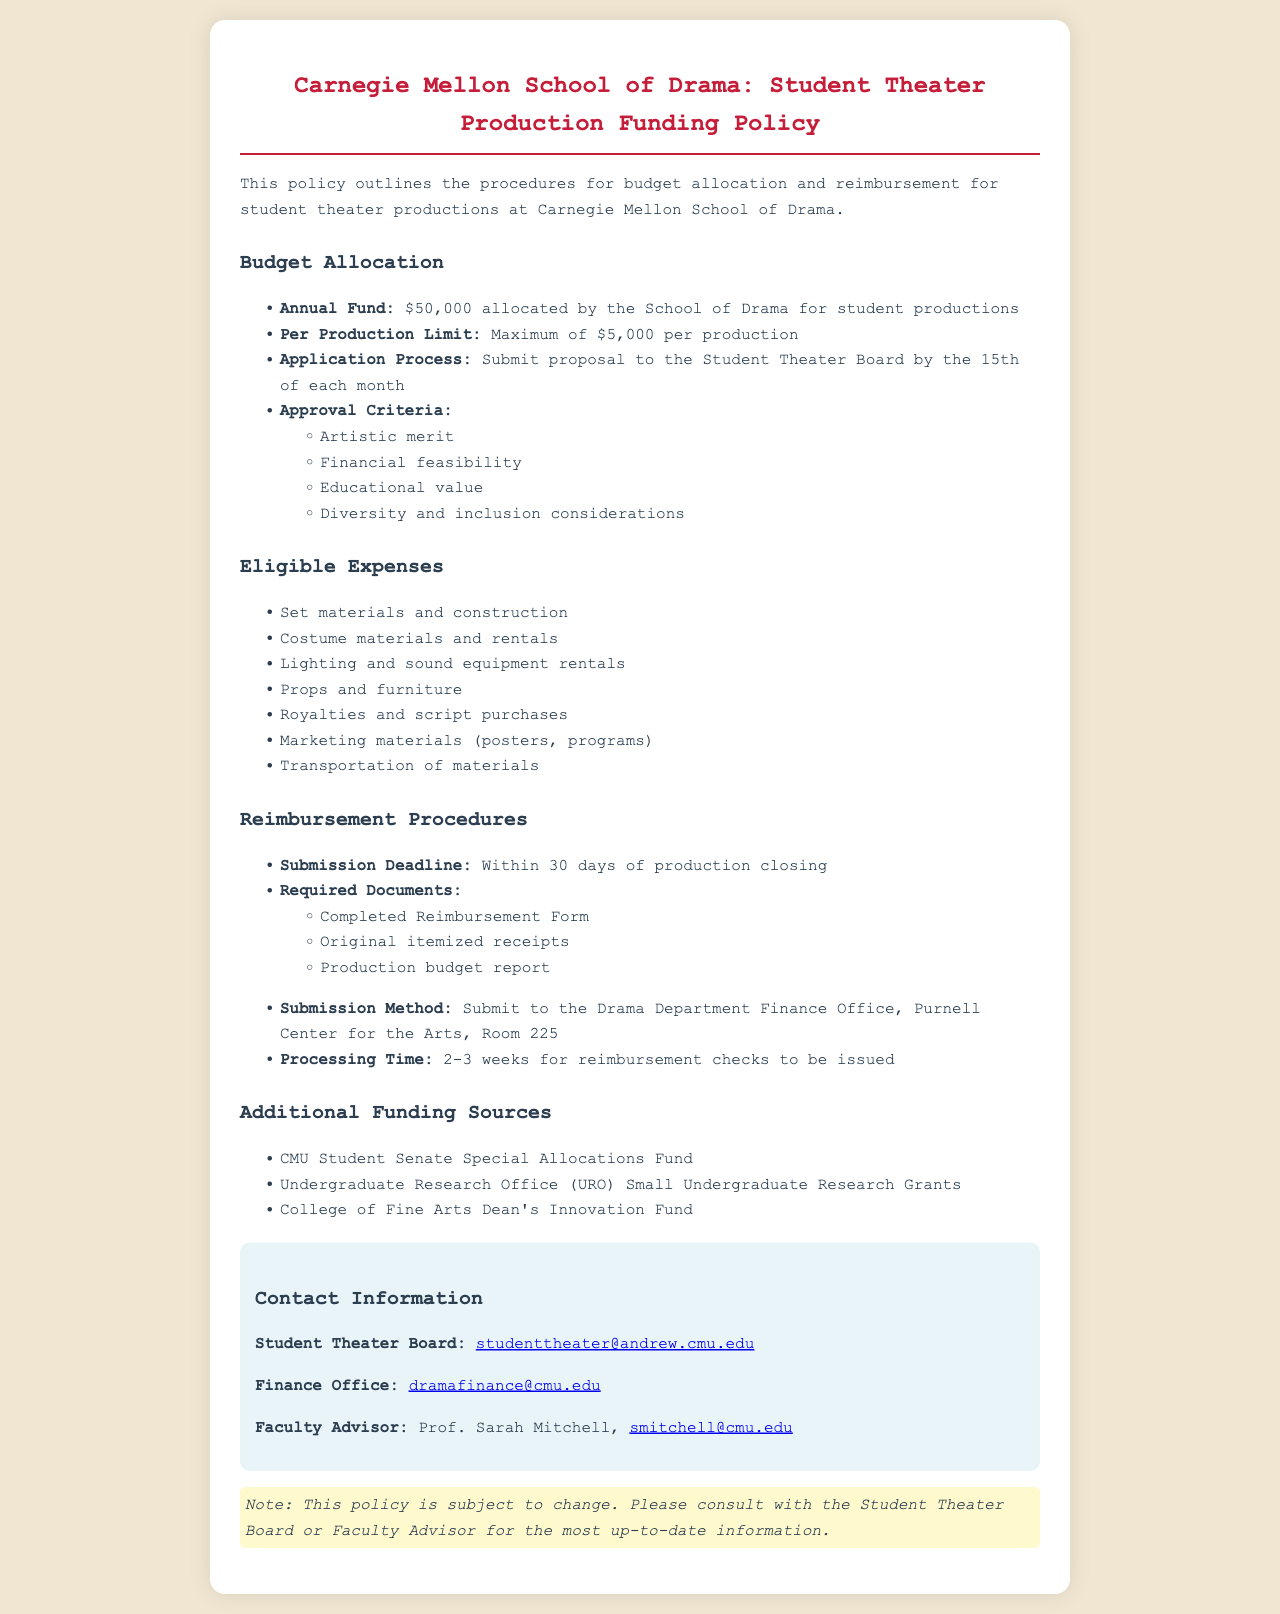What is the annual fund amount? The document states that the annual fund allocated by the School of Drama for student productions is $50,000.
Answer: $50,000 What is the maximum funding per production? The document mentions that the maximum funding available per production is $5,000.
Answer: $5,000 When must proposals be submitted? According to the document, proposals must be submitted to the Student Theater Board by the 15th of each month.
Answer: 15th of each month What are the four approval criteria? The document outlines approval criteria, which include artistic merit, financial feasibility, educational value, and diversity and inclusion considerations.
Answer: Artistic merit, financial feasibility, educational value, diversity and inclusion considerations What is required for reimbursement submission? The document specifies that a completed reimbursement form, original itemized receipts, and a production budget report are required for submission.
Answer: Completed Reimbursement Form, original itemized receipts, production budget report How long does it take to process reimbursement checks? The document indicates that it takes 2-3 weeks for reimbursement checks to be issued.
Answer: 2-3 weeks Who is the Faculty Advisor? The document lists Prof. Sarah Mitchell as the Faculty Advisor.
Answer: Prof. Sarah Mitchell Where should reimbursement submissions be sent? The document states that submissions should be sent to the Drama Department Finance Office, Purnell Center for the Arts, Room 225.
Answer: Drama Department Finance Office, Purnell Center for the Arts, Room 225 